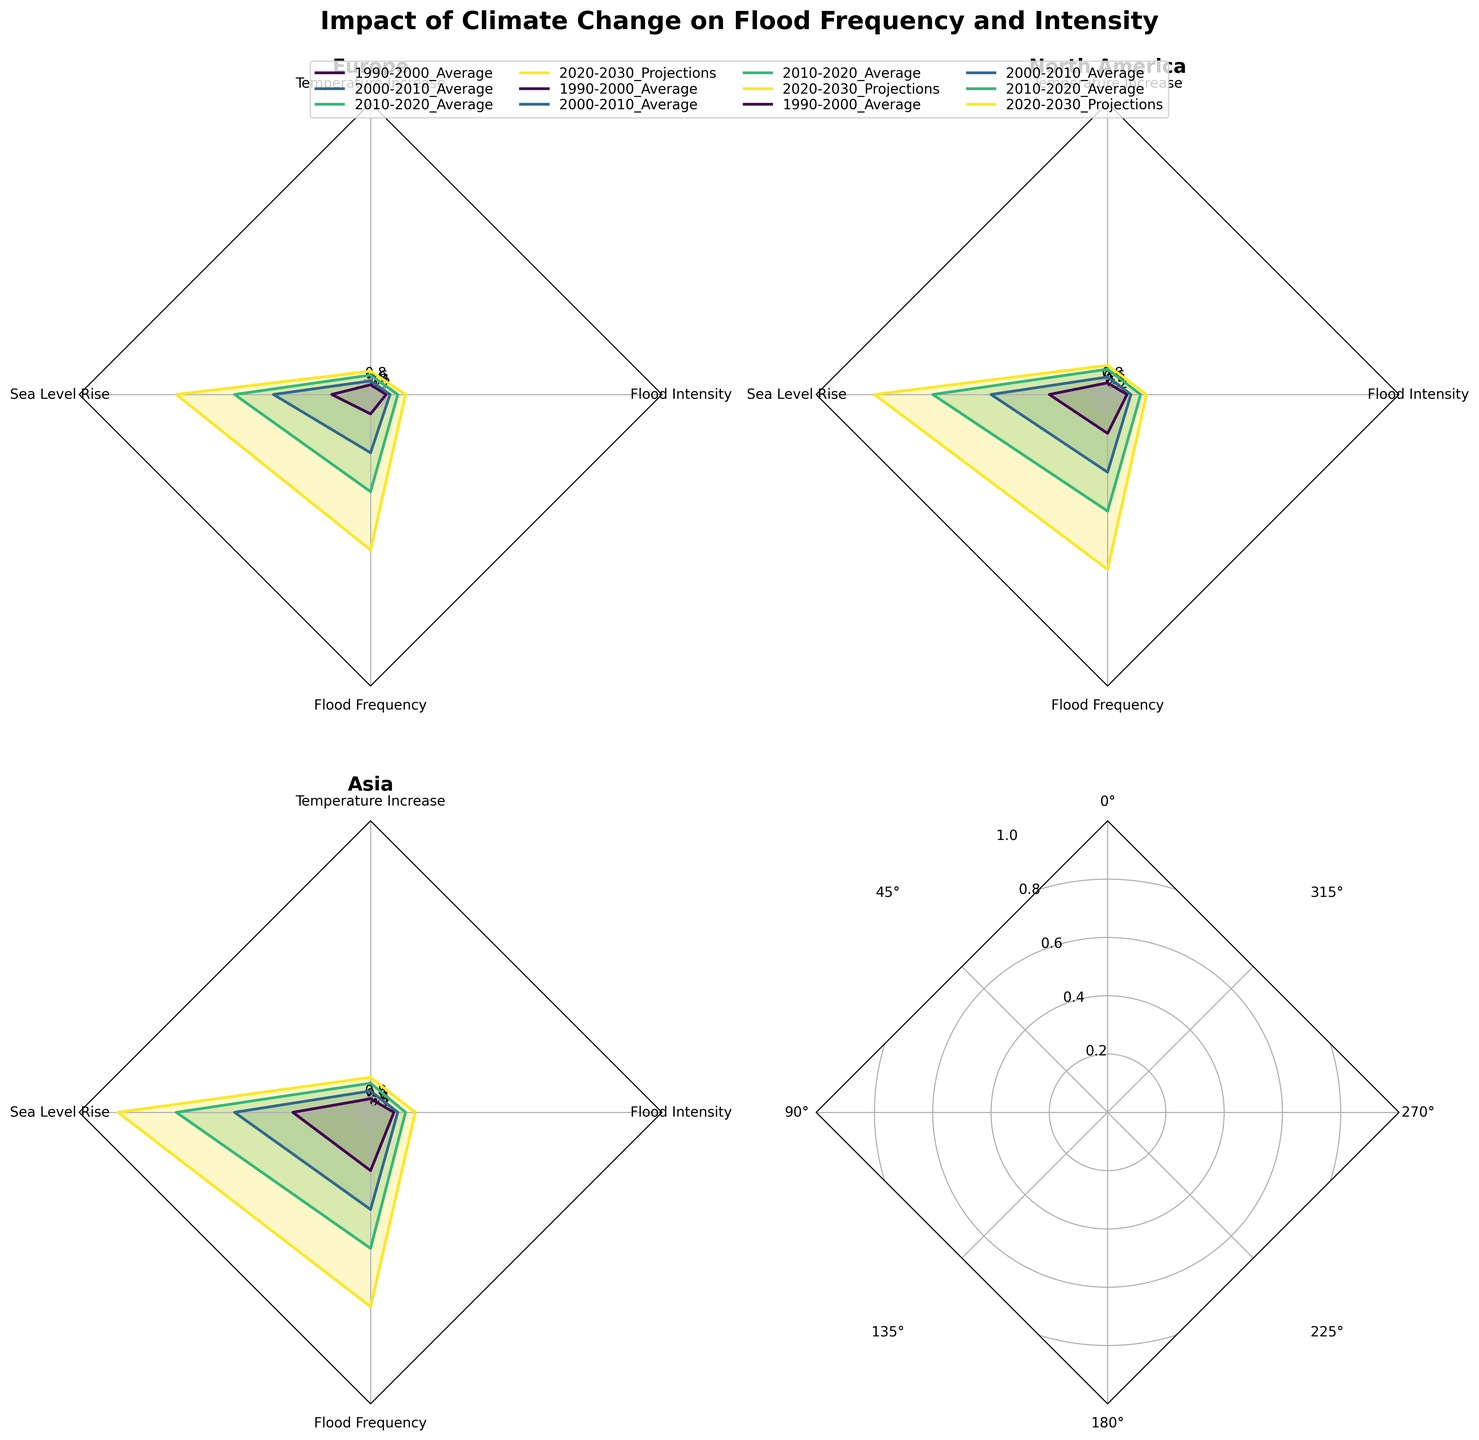What periods are compared in the radar charts? The legend above the figure lists the periods being compared. They are '1990-2000 Average', '2000-2010 Average', '2010-2020 Average', and '2020-2030 Projections'.
Answer: Four periods Which region shows the highest projected flood frequency for 2020-2030? Observe the lines and shading in each radar subplot for the 'Flood Frequency' category for 2020-2030. The Asia region shows the highest value in that category.
Answer: Asia By how much is the sea level rise in North America projected to increase from 2010-2020 to 2020-2030? In the North America subplot, observe the 'Sea Level Rise' category for 2010-2020 and 2020-2030 Projections. The values are 9 and 12, respectively. The increase is 12 - 9.
Answer: 3 units How do the projected flood intensities for 2020-2030 compare across all regions? Check the 2020-2030 Projections line for the 'Flood Intensity' category in each regional subplot. The flood intensities for Europe, North America, and Asia are about 1.8, 2.0, and 2.3, respectively.
Answer: Asia > North America > Europe What is the trend in temperature increase for Asia from 1990 to 2030? Follow the 'Temperature Increase' plot line for Asia from 1990-2000 to 2020-2030. The points are increasing from 0.7 to 1.1 to 1.5 to 1.8, showing a rising trend.
Answer: Increasing trend What's the average sea level rise in Europe from 1990 to 2020? The sea level rise values for Europe from 1990-2000, 2000-2010, and 2010-2020 are 2, 5, and 7, respectively. Thus, the average is (2+5+7)/3 = 14/3.
Answer: Approximately 4.67 Which region has the most balanced growth across all categories in the projected 2020-2030 data? Check the consistency and closeness in the lengths of the 2020-2030 Projections values across the four categories in each region. North America has more balanced growth in temperature increase, sea level rise, flood frequency, and flood intensity.
Answer: North America What does the radar chart's title indicates about this analysis? The title at the top of the figure states "Impact of Climate Change on Flood Frequency and Intensity", indicating an analysis of how climate change impacts these two specific parameters over time and across regions.
Answer: Impact of Climate Change 